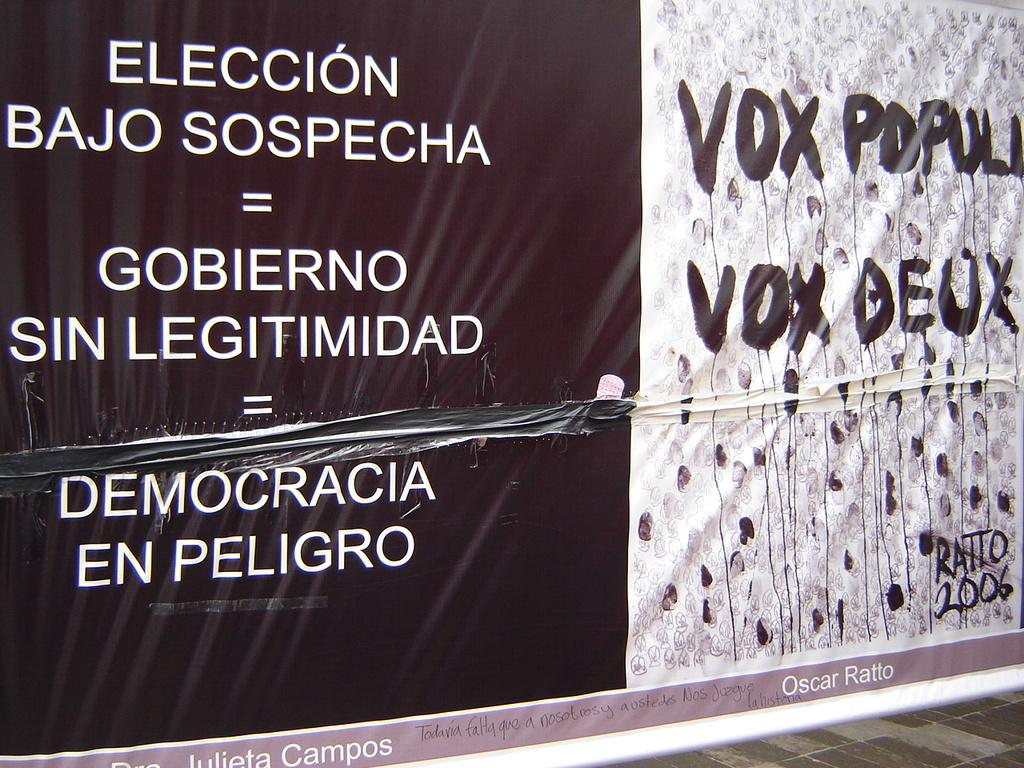<image>
Create a compact narrative representing the image presented. A poster in Spanish about an election which is "Eleccion" in Spanish. 